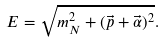Convert formula to latex. <formula><loc_0><loc_0><loc_500><loc_500>E = \sqrt { m _ { N } ^ { 2 } + ( \vec { p } + \vec { \alpha } ) ^ { 2 } } .</formula> 